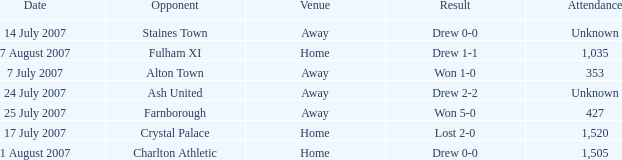Name the attendance with result of won 1-0 353.0. 